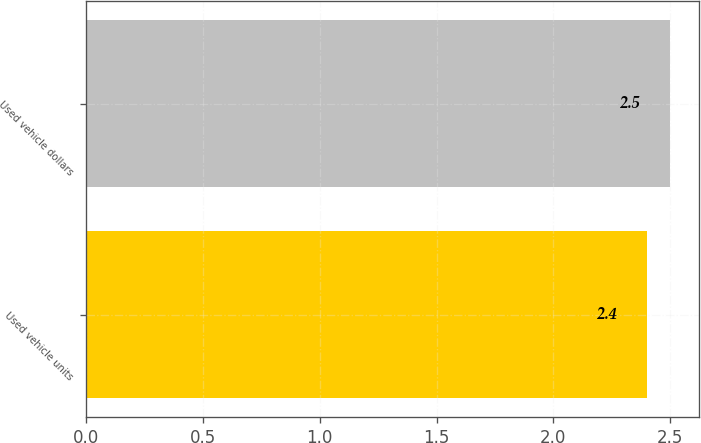<chart> <loc_0><loc_0><loc_500><loc_500><bar_chart><fcel>Used vehicle units<fcel>Used vehicle dollars<nl><fcel>2.4<fcel>2.5<nl></chart> 